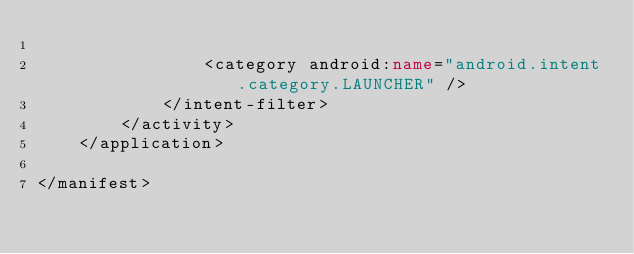Convert code to text. <code><loc_0><loc_0><loc_500><loc_500><_XML_>
                <category android:name="android.intent.category.LAUNCHER" />
            </intent-filter>
        </activity>
    </application>

</manifest></code> 